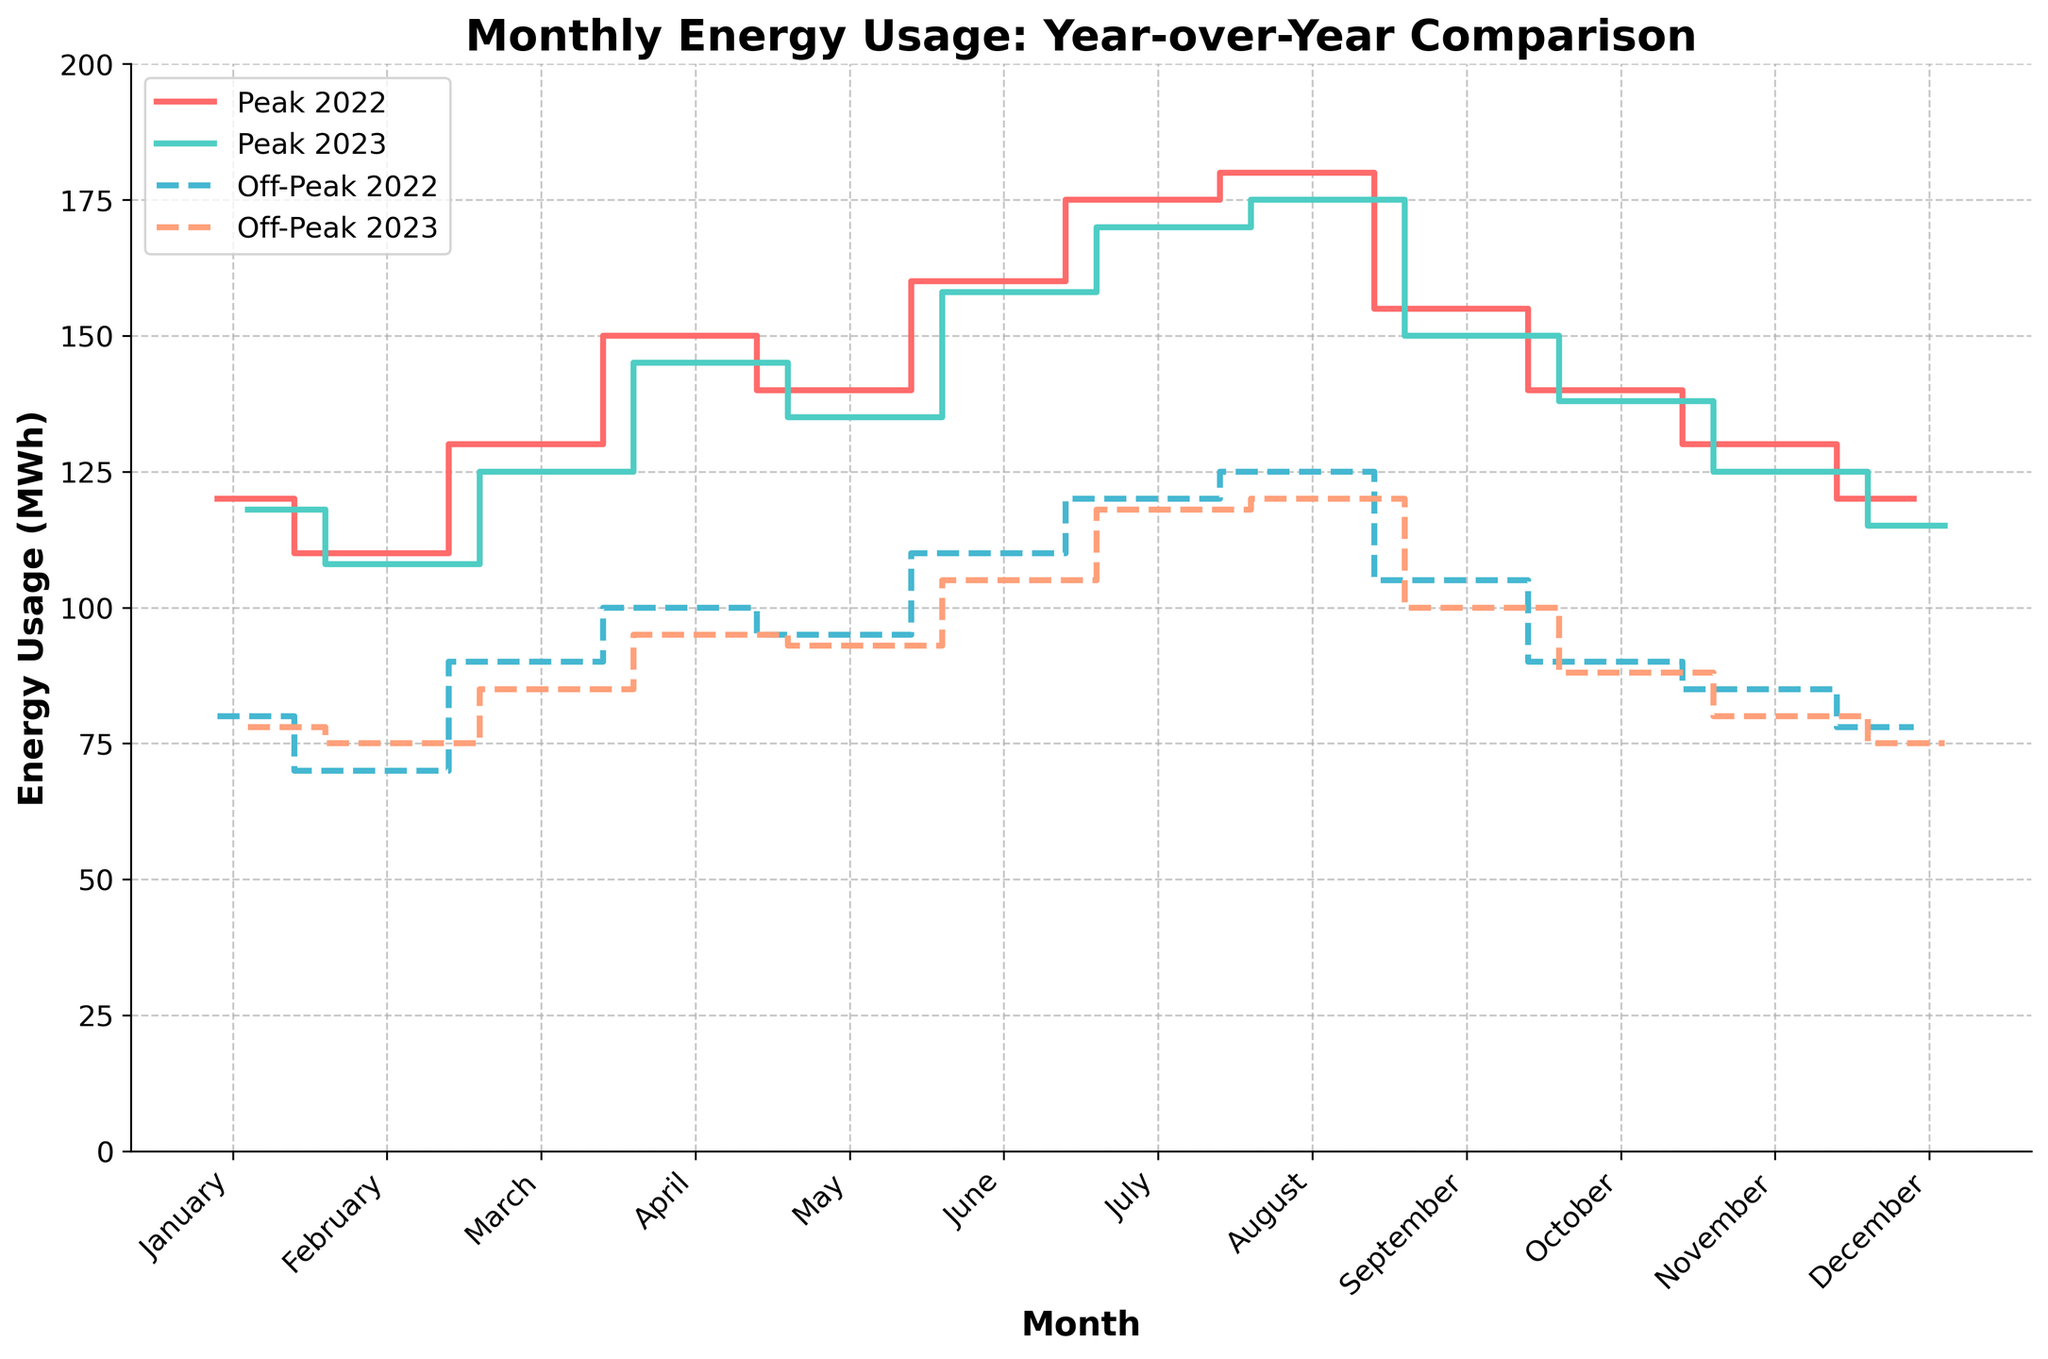What is the title of the plot? The title of the plot is displayed at the top center of the figure, which reads "Monthly Energy Usage: Year-over-Year Comparison".
Answer: Monthly Energy Usage: Year-over-Year Comparison What does the x-axis represent? The label on the x-axis indicates that it represents months of the year, with tick marks for each month from January to December.
Answer: Month What does the y-axis represent? The label on the y-axis indicates that it represents energy usage in megawatt-hours (MWh).
Answer: Energy Usage (MWh) Which color represents the peak usage for the year 2023? The legend in the plot shows that the color associated with peak usage in 2023 is a teal color.
Answer: Teal Which month showed the highest peak energy usage in 2022? By analyzing the peak energy usage line for 2022, the month with the highest value appears to be August, as it reaches the highest point on the y-axis among all the months.
Answer: August How does off-peak usage in January 2023 compare to January 2022? Reviewing the plot, the off-peak usage for January 2023 is represented by a line slightly below the line for January 2022, indicating a slight decrease in off-peak usage for January 2023 compared to January 2022.
Answer: It decreased What's the average peak usage for June across both years? To find the average peak usage for June, add the peak values for June 2022 and June 2023, which are 160 MWh and 158 MWh respectively, then divide by 2. (160 + 158) / 2 = 159
Answer: 159 MWh Which year shows a more pronounced difference between peak and off-peak usage in July? Looking at the height of the steps for July in both years, the difference in the height of the lines representing peak and off-peak usage appears greater in 2022 compared to 2023.
Answer: 2022 Is there any month where peak usage is the same for both years? By examining the step plots for both years, there is no month where the peak usage lines for the two years coincide at the same point.
Answer: No What is the trend in off-peak energy usage from November to December in 2023? Reviewing the off-peak energy usage line for 2023 from November to December, it shows a slight decrease.
Answer: Decreasing 